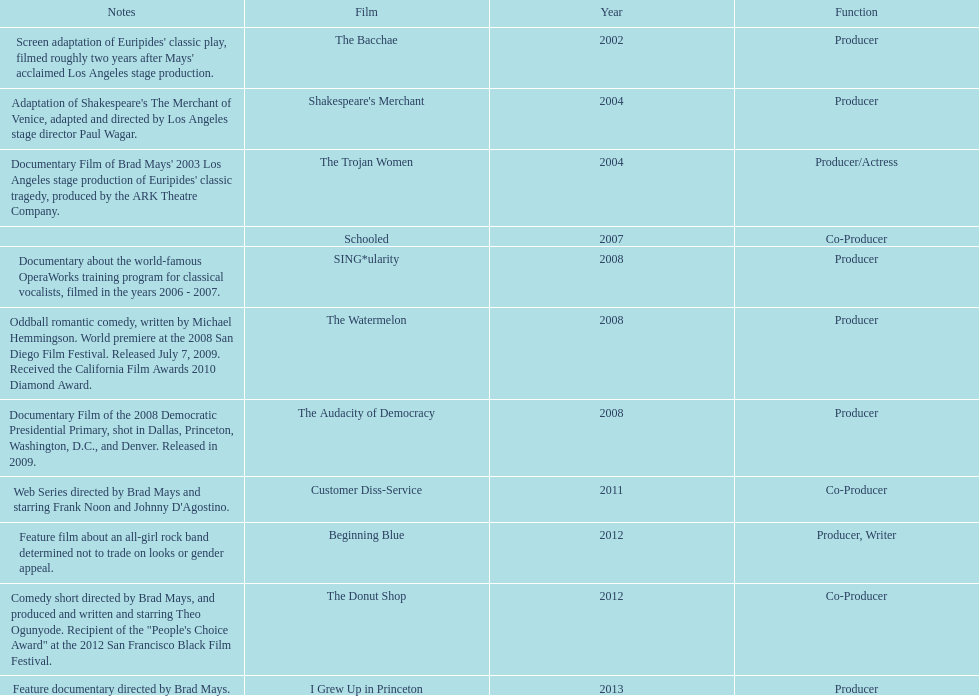How many films did ms. starfelt produce after 2010? 4. 